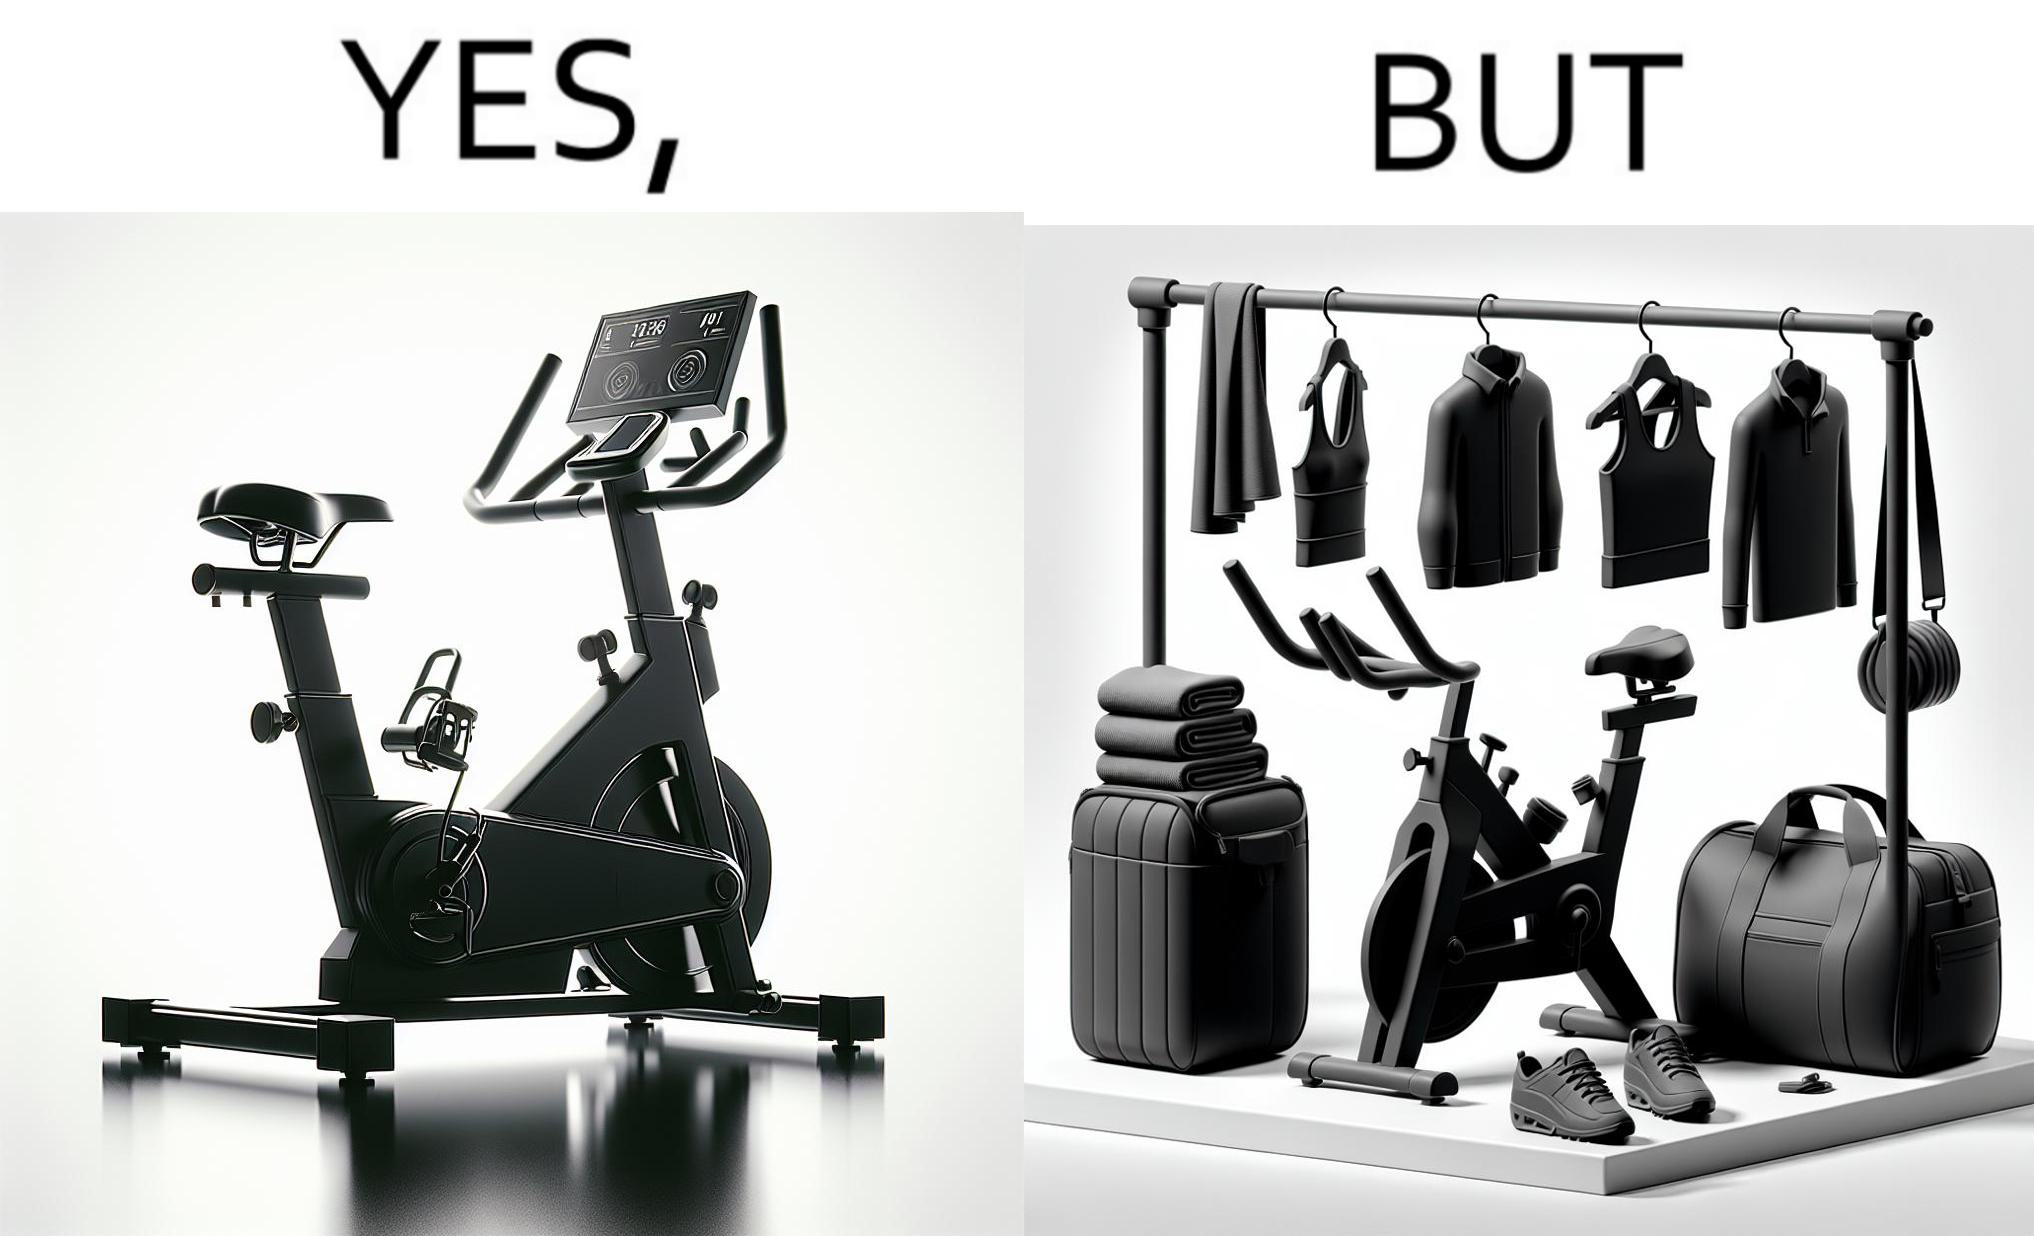Describe what you see in this image. This is a satirical image with contrasting elements. 